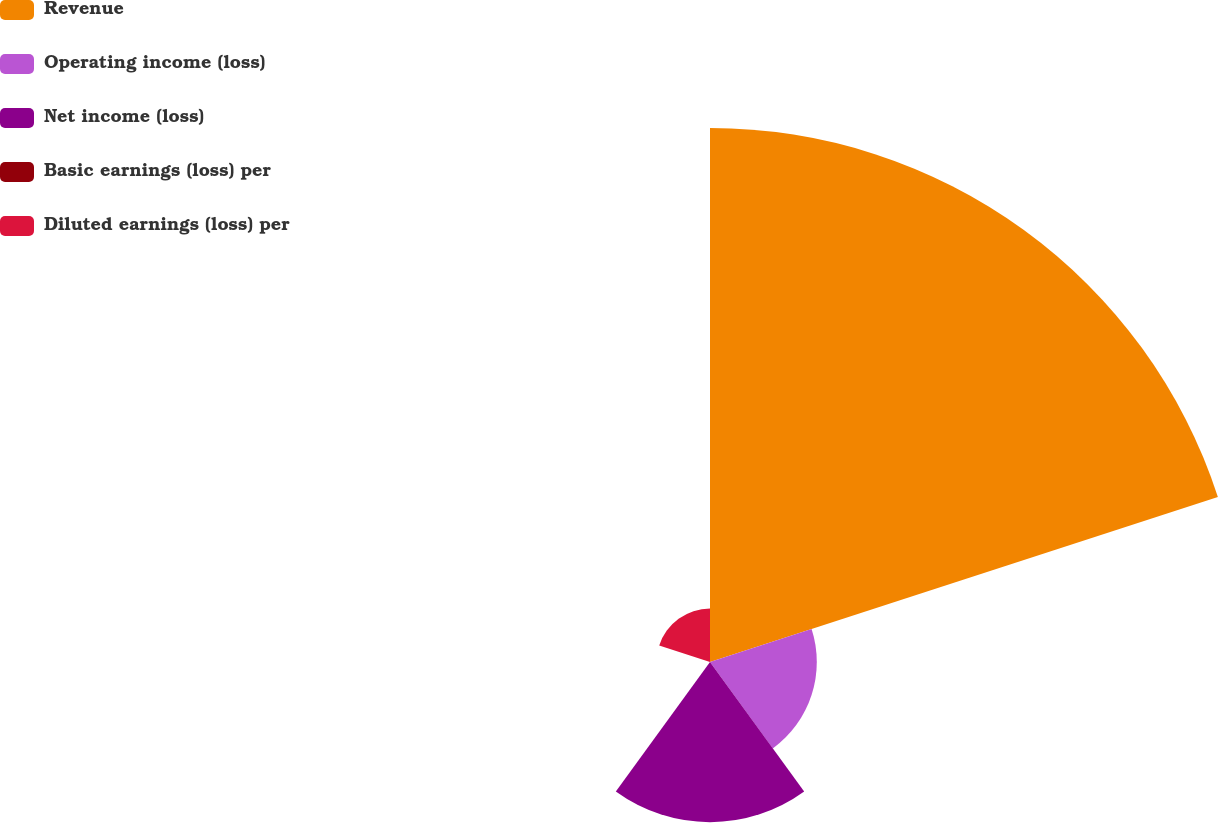<chart> <loc_0><loc_0><loc_500><loc_500><pie_chart><fcel>Revenue<fcel>Operating income (loss)<fcel>Net income (loss)<fcel>Basic earnings (loss) per<fcel>Diluted earnings (loss) per<nl><fcel>62.5%<fcel>12.5%<fcel>18.75%<fcel>0.0%<fcel>6.25%<nl></chart> 